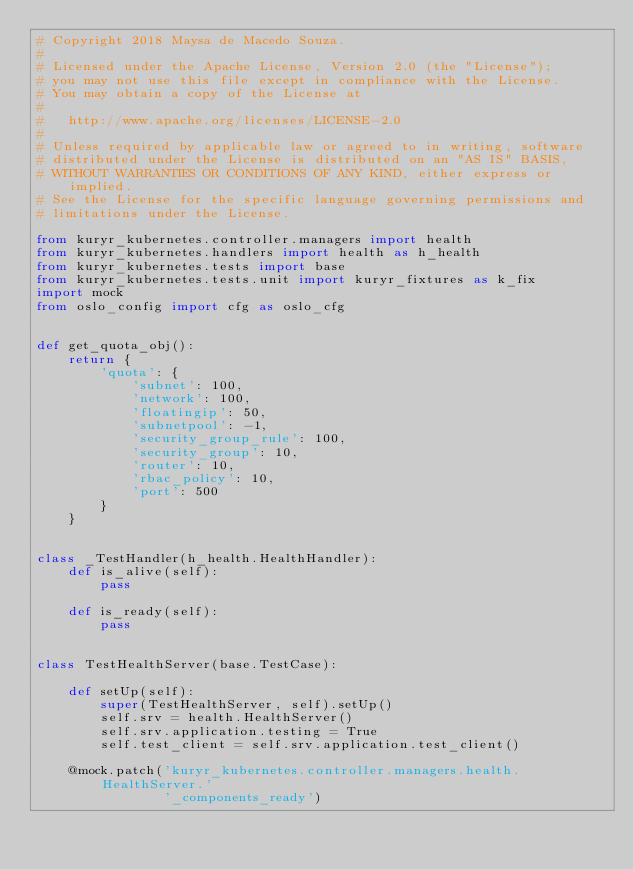Convert code to text. <code><loc_0><loc_0><loc_500><loc_500><_Python_># Copyright 2018 Maysa de Macedo Souza.
#
# Licensed under the Apache License, Version 2.0 (the "License");
# you may not use this file except in compliance with the License.
# You may obtain a copy of the License at
#
#   http://www.apache.org/licenses/LICENSE-2.0
#
# Unless required by applicable law or agreed to in writing, software
# distributed under the License is distributed on an "AS IS" BASIS,
# WITHOUT WARRANTIES OR CONDITIONS OF ANY KIND, either express or implied.
# See the License for the specific language governing permissions and
# limitations under the License.

from kuryr_kubernetes.controller.managers import health
from kuryr_kubernetes.handlers import health as h_health
from kuryr_kubernetes.tests import base
from kuryr_kubernetes.tests.unit import kuryr_fixtures as k_fix
import mock
from oslo_config import cfg as oslo_cfg


def get_quota_obj():
    return {
        'quota': {
            'subnet': 100,
            'network': 100,
            'floatingip': 50,
            'subnetpool': -1,
            'security_group_rule': 100,
            'security_group': 10,
            'router': 10,
            'rbac_policy': 10,
            'port': 500
        }
    }


class _TestHandler(h_health.HealthHandler):
    def is_alive(self):
        pass

    def is_ready(self):
        pass


class TestHealthServer(base.TestCase):

    def setUp(self):
        super(TestHealthServer, self).setUp()
        self.srv = health.HealthServer()
        self.srv.application.testing = True
        self.test_client = self.srv.application.test_client()

    @mock.patch('kuryr_kubernetes.controller.managers.health.HealthServer.'
                '_components_ready')</code> 